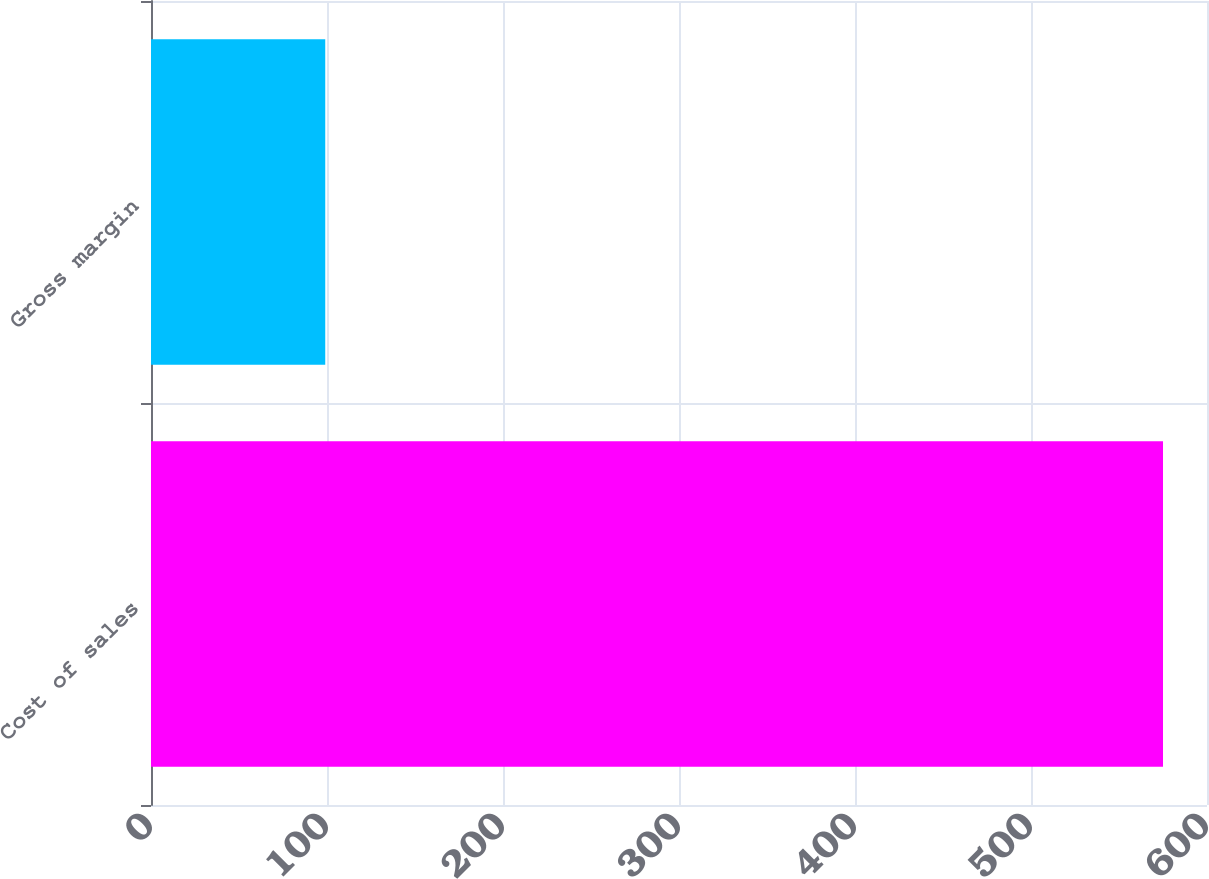Convert chart. <chart><loc_0><loc_0><loc_500><loc_500><bar_chart><fcel>Cost of sales<fcel>Gross margin<nl><fcel>575<fcel>99<nl></chart> 